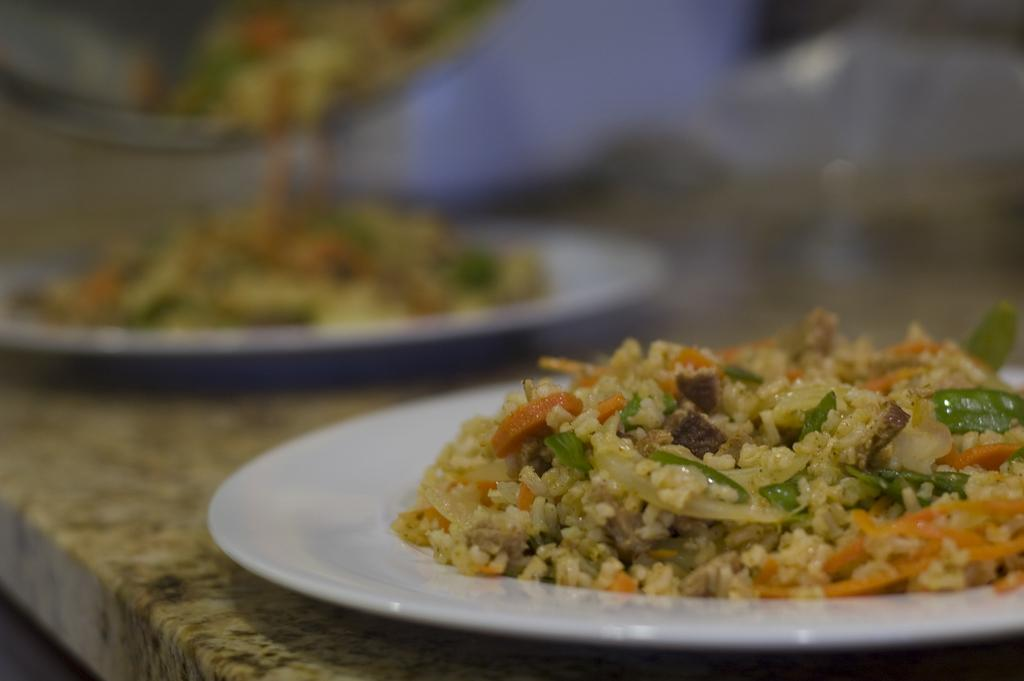What is on the plates in the image? There are food items on white color plates in the image. Where are the plates placed? The plates are on a stone surface. Can you describe the background of the image? The background of the image is blurred. What type of paper is visible in the image? There is no paper present in the image. Is there any indication of a disease in the image? There is no indication of a disease in the image. 